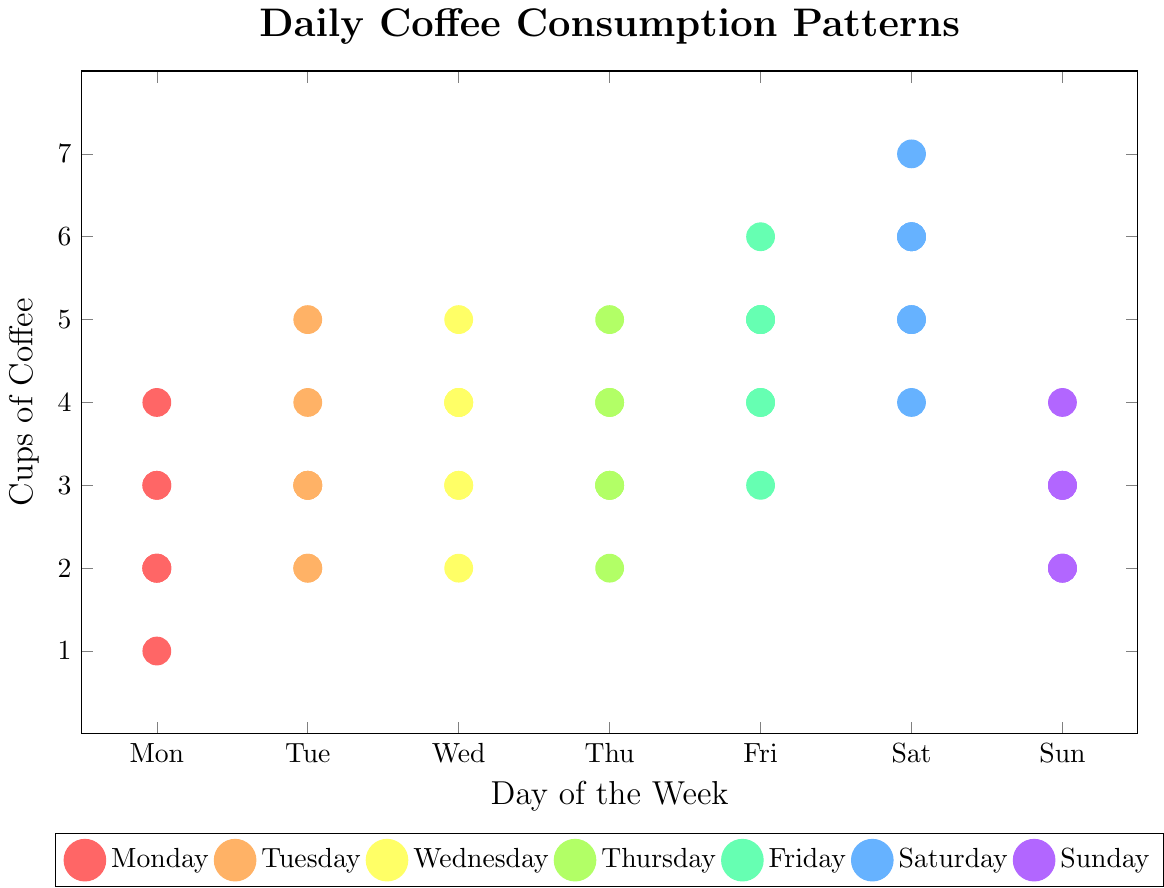How many cups of coffee were consumed on Monday? Count the dots that correspond to Monday. There are 5 dots for Monday, each representing 2, 3, 2, 4, 3, 1, and 2 cups. Summing these values: 2 + 3 + 2 + 4 + 3 + 1 + 2 = 17
Answer: 17 Which day had the highest coffee consumption? Group the data by each day and find the maximum value. Saturday has the highest individual consumption of 7 cups.
Answer: Saturday What is the average number of cups of coffee consumed on Wednesday? Wednesday has the values 4, 3, 5, 2, 4, 3, 4. Sum these values: 4 + 3 + 5 + 2 + 4 + 3 + 4 = 25. There are 7 values, so the average is 25/7 ≈ 3.57
Answer: 3.57 Which day has more even coffee consumption: Tuesday or Friday? Compare the range of values for each day. Tuesday's values (3, 4, 2, 3, 5, 2, 3) range from 2 to 5, while Friday's values (5, 4, 6, 3, 5, 4, 5) range from 3 to 6. Tuesday has a smaller range.
Answer: Tuesday Are there any days where the number of cups of coffee consumed never exceeds 5? List the maximum values for each day: Monday (4), Tuesday (5), Wednesday (5), Thursday (5), Friday (6), Saturday (7), Sunday (4). Monday and Sunday never exceed 5 cups.
Answer: Monday, Sunday Which day has the most variation in coffee consumption? Use the range (difference between maximum and minimum values): 
- Monday (1 to 4) => 3
- Tuesday (2 to 5) => 3
- Wednesday (2 to 5) => 3
- Thursday (2 to 5) => 3
- Friday (3 to 6) => 3
- Saturday (4 to 7) => 3
- Sunday (2 to 4) => 2
All days except Sunday have the same variation.
Answer: All except Sunday Count the number of days that have at least one occasion of 5 or more cups of coffee. Identify days with at least one occurrence of 5 or more cups:
- Monday: 0
- Tuesday: 1 day
- Wednesday: 1 day
- Thursday: 1 day
- Friday: 4 days
- Saturday: 6 days
- Sunday: 0
Count of such days: Tuesday, Wednesday, Thursday, Friday, Saturday => 5 days
Answer: 5 Is there a day where exactly 3 cups were consumed more often than any other day? Count occurrences of exactly 3 cups per day:
- Monday: 2
- Tuesday: 3
- Wednesday: 2
- Thursday: 3
- Friday: 1
- Saturday: 0
- Sunday: 3
Three days (Tuesday, Thursday, Sunday) have the highest with 3 occurrences each.
Answer: Tuesday, Thursday, Sunday What's the range of coffee consumption on Sunday? The values for Sunday are 3, 2, 4, 3, 2, 3, 2. The difference between the highest (4) and lowest (2) values is 2.
Answer: 2 